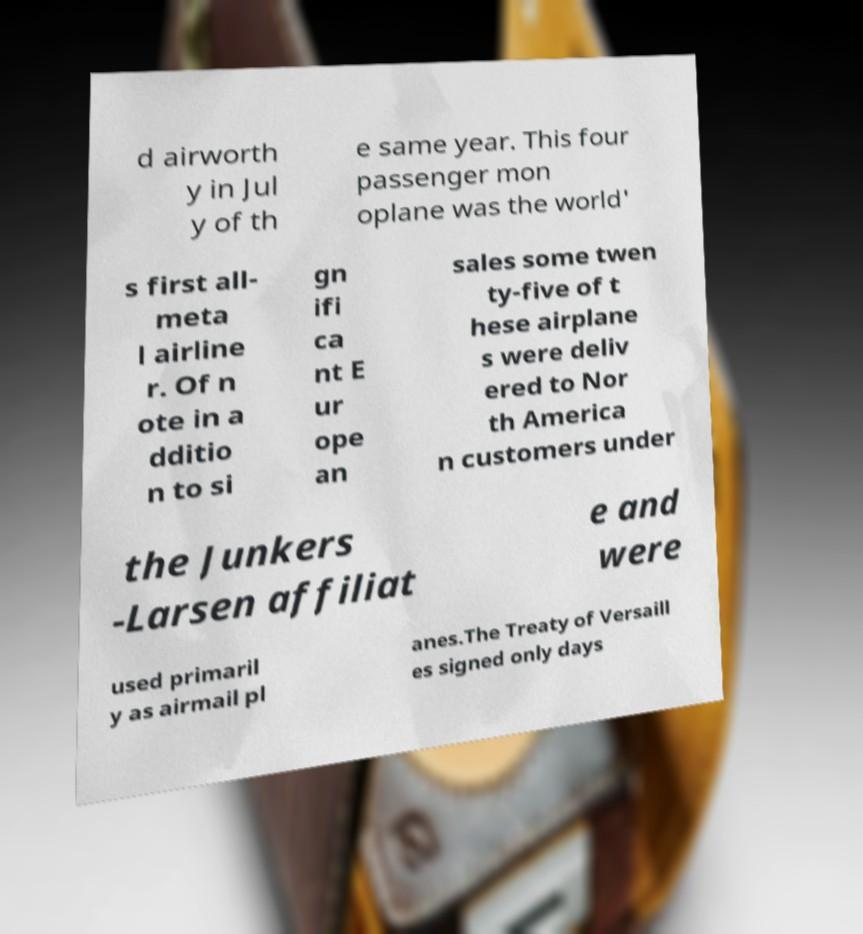What messages or text are displayed in this image? I need them in a readable, typed format. d airworth y in Jul y of th e same year. This four passenger mon oplane was the world' s first all- meta l airline r. Of n ote in a dditio n to si gn ifi ca nt E ur ope an sales some twen ty-five of t hese airplane s were deliv ered to Nor th America n customers under the Junkers -Larsen affiliat e and were used primaril y as airmail pl anes.The Treaty of Versaill es signed only days 